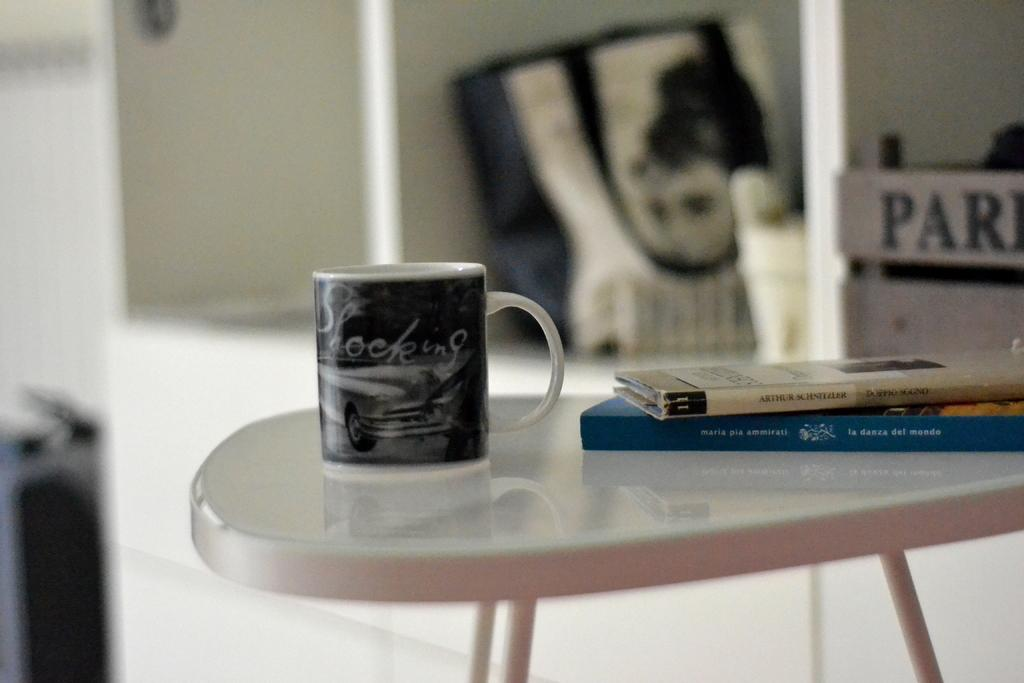What piece of furniture is present in the image? There is a table in the image. What object can be seen on the table? There is a cup on the table. What else is on the table besides the cup? There are books on the table. What color is the eye of the person in the image? There is no person present in the image, so there is no eye to observe. 